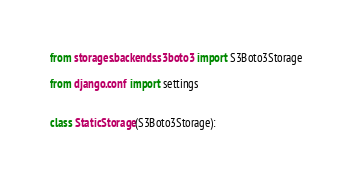<code> <loc_0><loc_0><loc_500><loc_500><_Python_>from storages.backends.s3boto3 import S3Boto3Storage

from django.conf import settings


class StaticStorage(S3Boto3Storage):</code> 